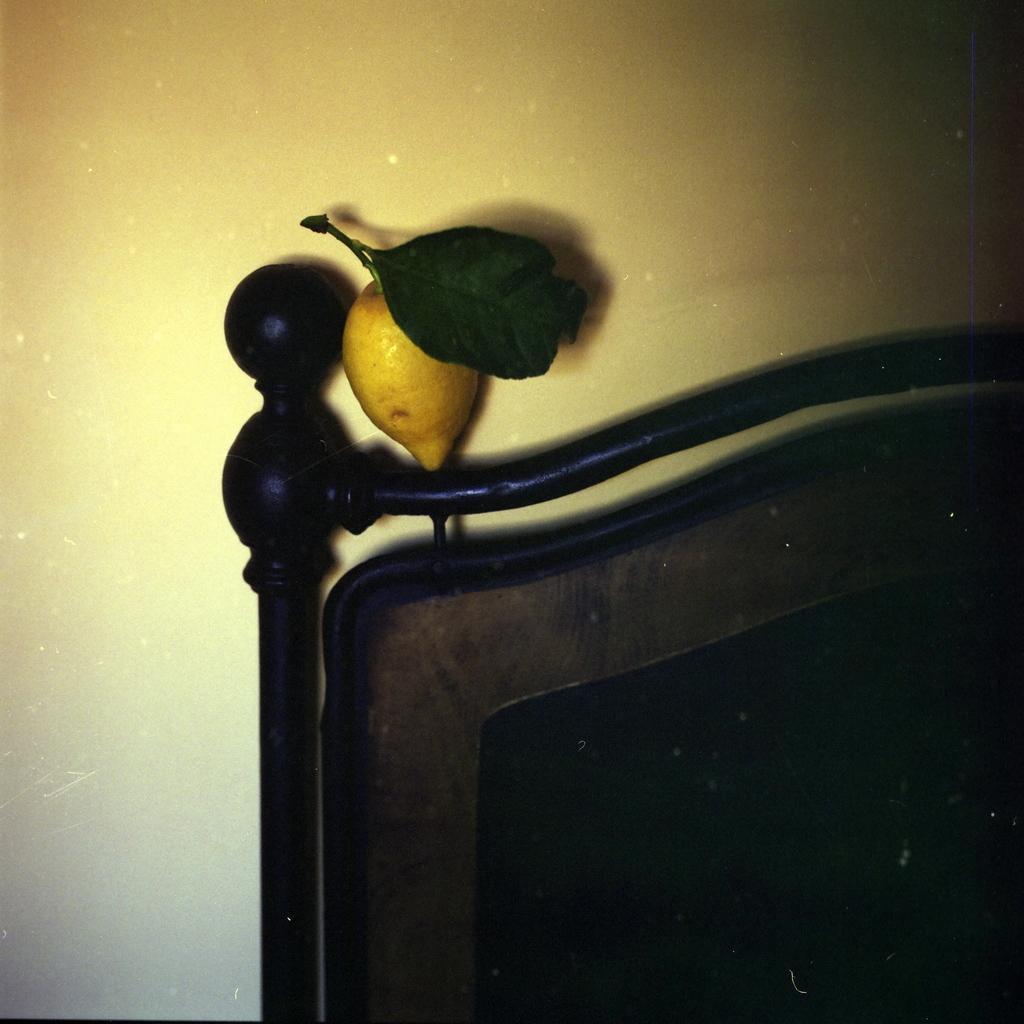Please provide a concise description of this image. In this picture there is a wooden object and there is a yellow color fruit on the wooden object. At the back it looks like a wall. 